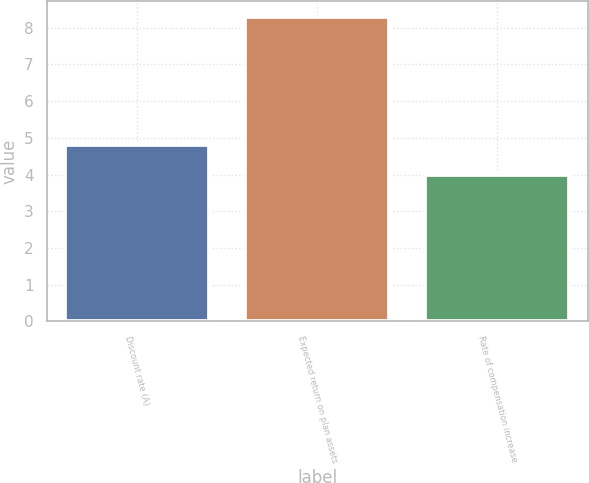Convert chart to OTSL. <chart><loc_0><loc_0><loc_500><loc_500><bar_chart><fcel>Discount rate (A)<fcel>Expected return on plan assets<fcel>Rate of compensation increase<nl><fcel>4.8<fcel>8.3<fcel>4<nl></chart> 